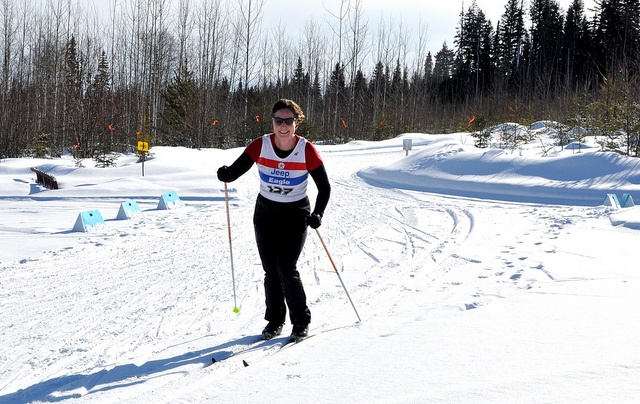Describe the objects in this image and their specific colors. I can see people in lightgray, black, darkgray, white, and gray tones and skis in lightgray, white, gray, black, and darkgray tones in this image. 